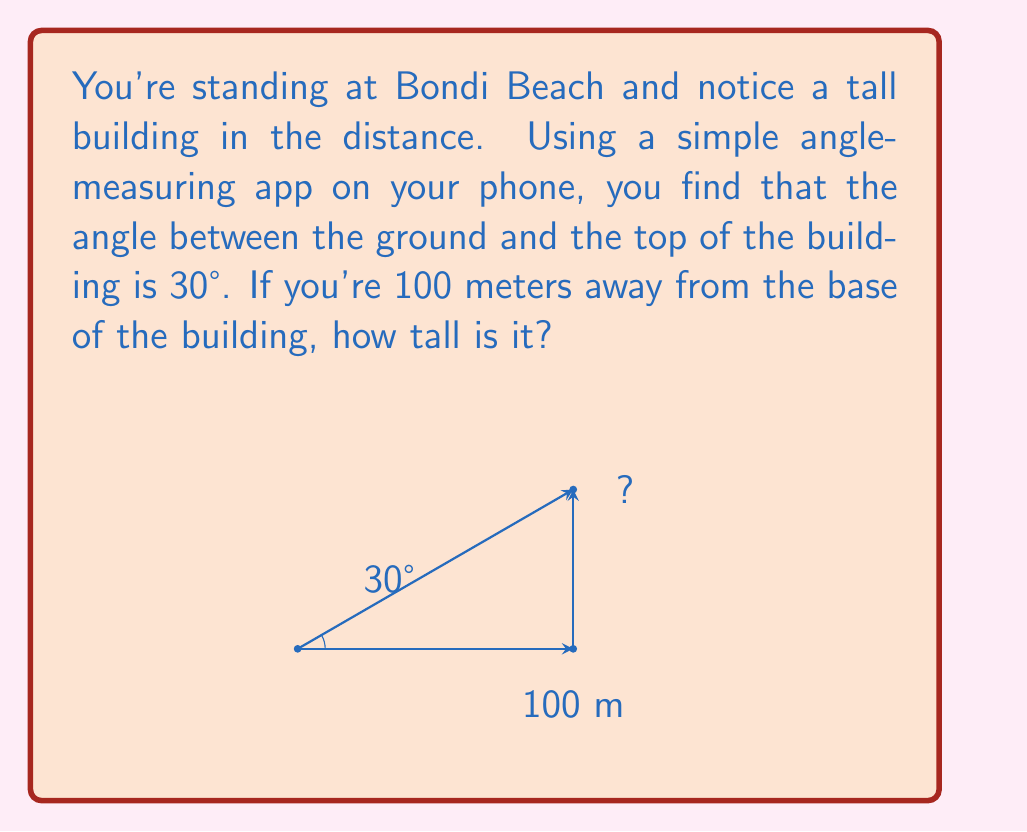Can you solve this math problem? Let's approach this step-by-step:

1) In this problem, we're dealing with a right-angled triangle. The building forms the vertical side (opposite to the 30° angle), the distance from us to the building is the horizontal side (adjacent to the 30° angle), and our line of sight to the top of the building forms the hypotenuse.

2) We know:
   - The angle is 30°
   - The adjacent side (distance to the building) is 100 meters

3) We need to find the opposite side (height of the building).

4) In a right-angled triangle, the tangent of an angle is the ratio of the opposite side to the adjacent side:

   $$ \tan(\theta) = \frac{\text{opposite}}{\text{adjacent}} $$

5) We can rearrange this to find the opposite side:

   $$ \text{opposite} = \text{adjacent} \times \tan(\theta) $$

6) Plugging in our values:

   $$ \text{height} = 100 \times \tan(30°) $$

7) The tangent of 30° is $\frac{1}{\sqrt{3}}$ or approximately 0.577.

8) So, our calculation becomes:

   $$ \text{height} = 100 \times 0.577 = 57.7 \text{ meters} $$

Therefore, the building is approximately 57.7 meters tall.
Answer: 57.7 meters 